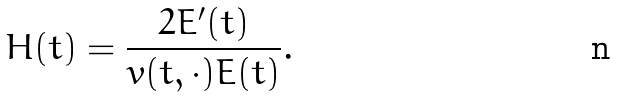<formula> <loc_0><loc_0><loc_500><loc_500>H ( t ) = \frac { 2 E ^ { \prime } ( t ) } { v ( t , \cdot ) E ( t ) } .</formula> 